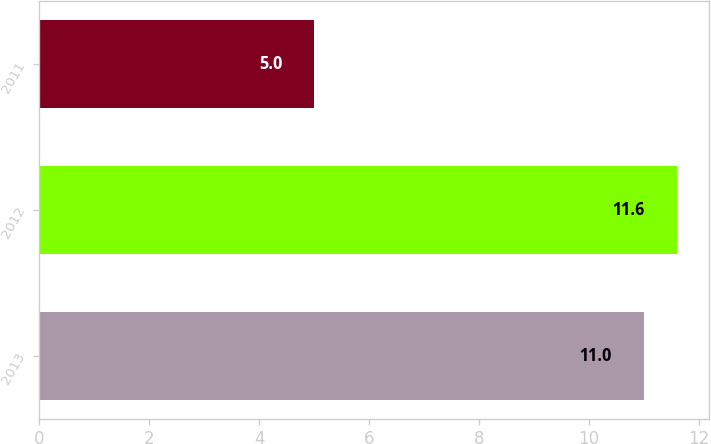<chart> <loc_0><loc_0><loc_500><loc_500><bar_chart><fcel>2013<fcel>2012<fcel>2011<nl><fcel>11<fcel>11.6<fcel>5<nl></chart> 